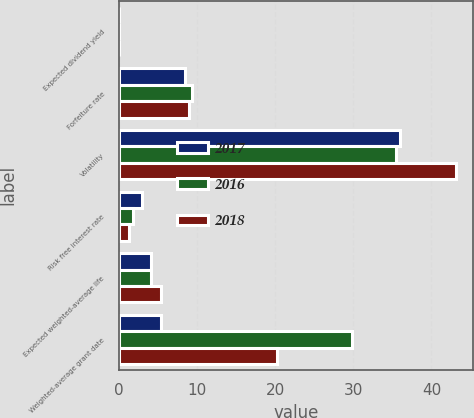Convert chart. <chart><loc_0><loc_0><loc_500><loc_500><stacked_bar_chart><ecel><fcel>Expected dividend yield<fcel>Forfeiture rate<fcel>Volatility<fcel>Risk free interest rate<fcel>Expected weighted-average life<fcel>Weighted-average grant date<nl><fcel>2017<fcel>0<fcel>8.4<fcel>35.93<fcel>2.96<fcel>4.11<fcel>5.33<nl><fcel>2016<fcel>0<fcel>9.37<fcel>35.49<fcel>1.77<fcel>4.13<fcel>29.86<nl><fcel>2018<fcel>0<fcel>9.01<fcel>43.14<fcel>1.29<fcel>5.33<fcel>20.18<nl></chart> 